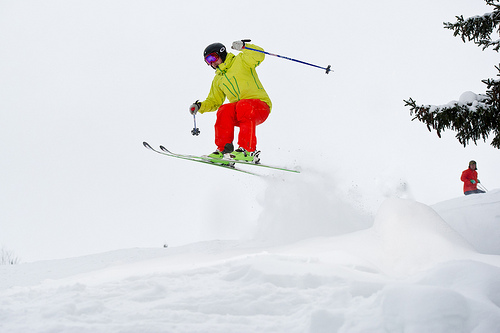Please provide the bounding box coordinate of the region this sentence describes: a ski pole the man is holding. The bounding box pinpointing the ski pole clutched in the skier's gloved hand as they navigate mid-air is [0.44, 0.23, 0.7, 0.34]. 